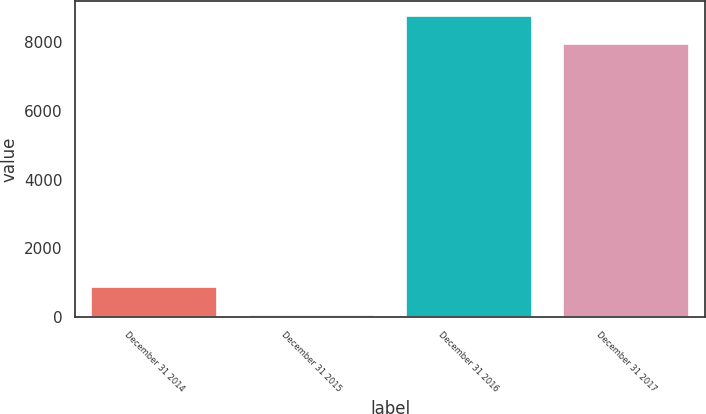Convert chart. <chart><loc_0><loc_0><loc_500><loc_500><bar_chart><fcel>December 31 2014<fcel>December 31 2015<fcel>December 31 2016<fcel>December 31 2017<nl><fcel>882.2<fcel>63<fcel>8752.2<fcel>7933<nl></chart> 